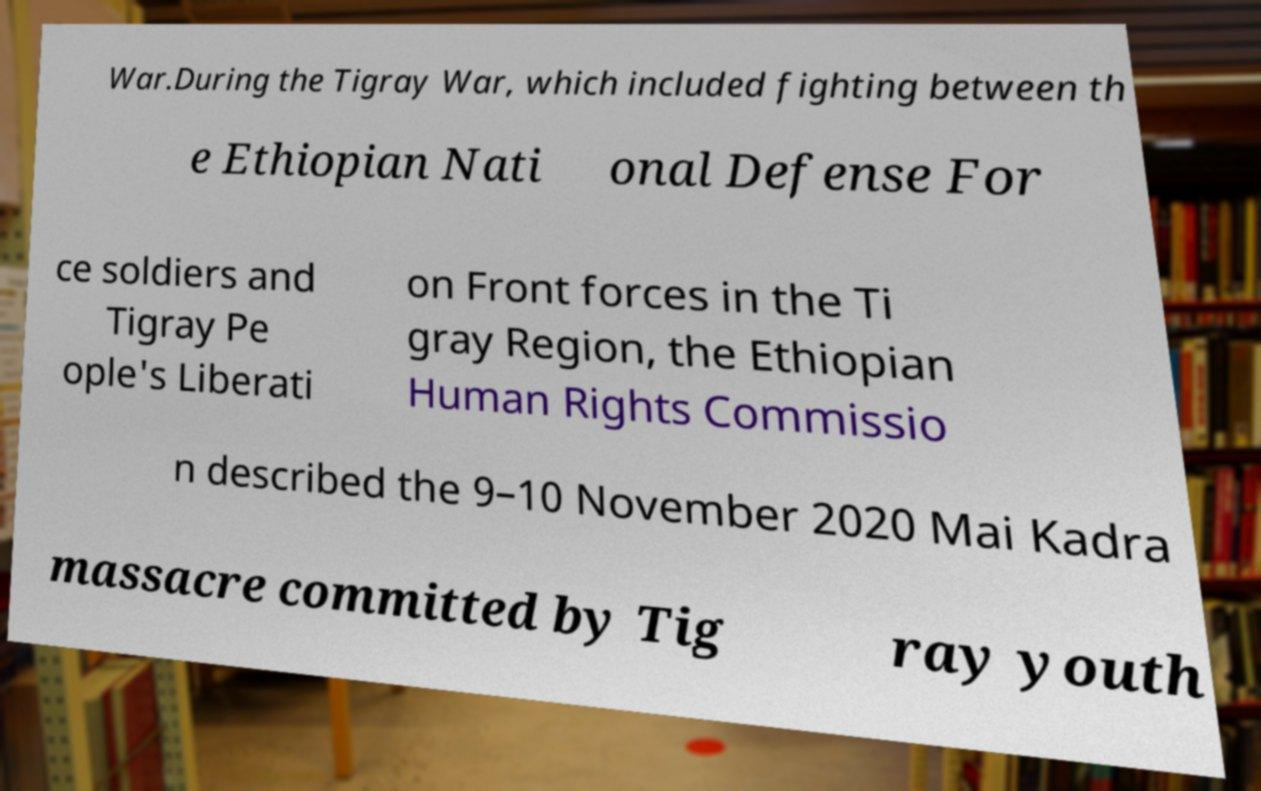Please read and relay the text visible in this image. What does it say? War.During the Tigray War, which included fighting between th e Ethiopian Nati onal Defense For ce soldiers and Tigray Pe ople's Liberati on Front forces in the Ti gray Region, the Ethiopian Human Rights Commissio n described the 9–10 November 2020 Mai Kadra massacre committed by Tig ray youth 